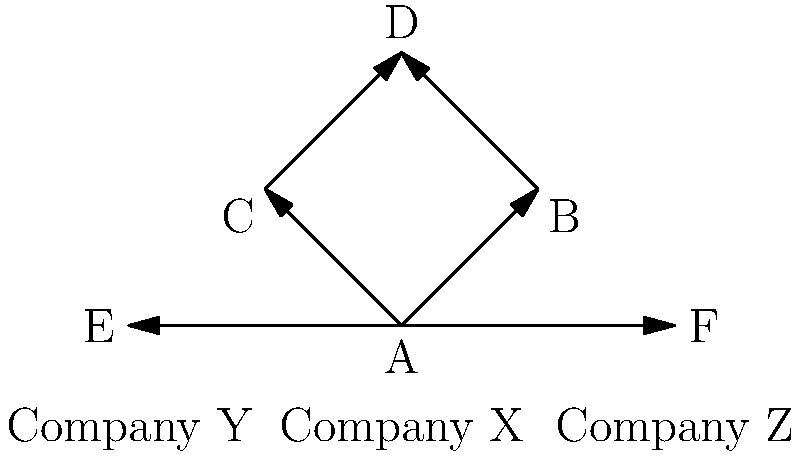In the given patent citation network for pharmaceutical companies, which company has the highest in-degree centrality, and what does this indicate about its role in the industry? To answer this question, we need to follow these steps:

1. Understand in-degree centrality:
   - In-degree centrality is the number of incoming edges to a node in a directed graph.
   - In the context of patent citations, it represents how many times a company's patents are cited by others.

2. Analyze the graph:
   - Company X (node A) has 0 incoming edges
   - Company Y (node E) has 1 incoming edge (from A)
   - Company Z (node F) has 1 incoming edge (from A)
   - Node B has 1 incoming edge (from A)
   - Node C has 1 incoming edge (from A)
   - Node D has 2 incoming edges (from B and C)

3. Identify the highest in-degree centrality:
   - Node D has the highest in-degree centrality with 2 incoming edges.

4. Interpret the result:
   - The node with the highest in-degree centrality (D) represents a patent or group of patents that are most frequently cited by others.
   - This indicates that the innovations represented by node D are likely foundational or highly influential in the pharmaceutical industry.
   - Although node D is not directly associated with a company in this graph, it suggests that the patents leading to this innovation are particularly important.

5. Industry implications:
   - High in-degree centrality in patent citation networks often indicates technological importance or fundamental breakthroughs.
   - Companies or researchers associated with highly cited patents may be considered industry leaders or key innovators.
   - From a practical standpoint, these patents may be crucial for future drug development or research directions in the pharmaceutical industry.
Answer: Node D; indicates highly influential or foundational innovations in the pharmaceutical industry. 